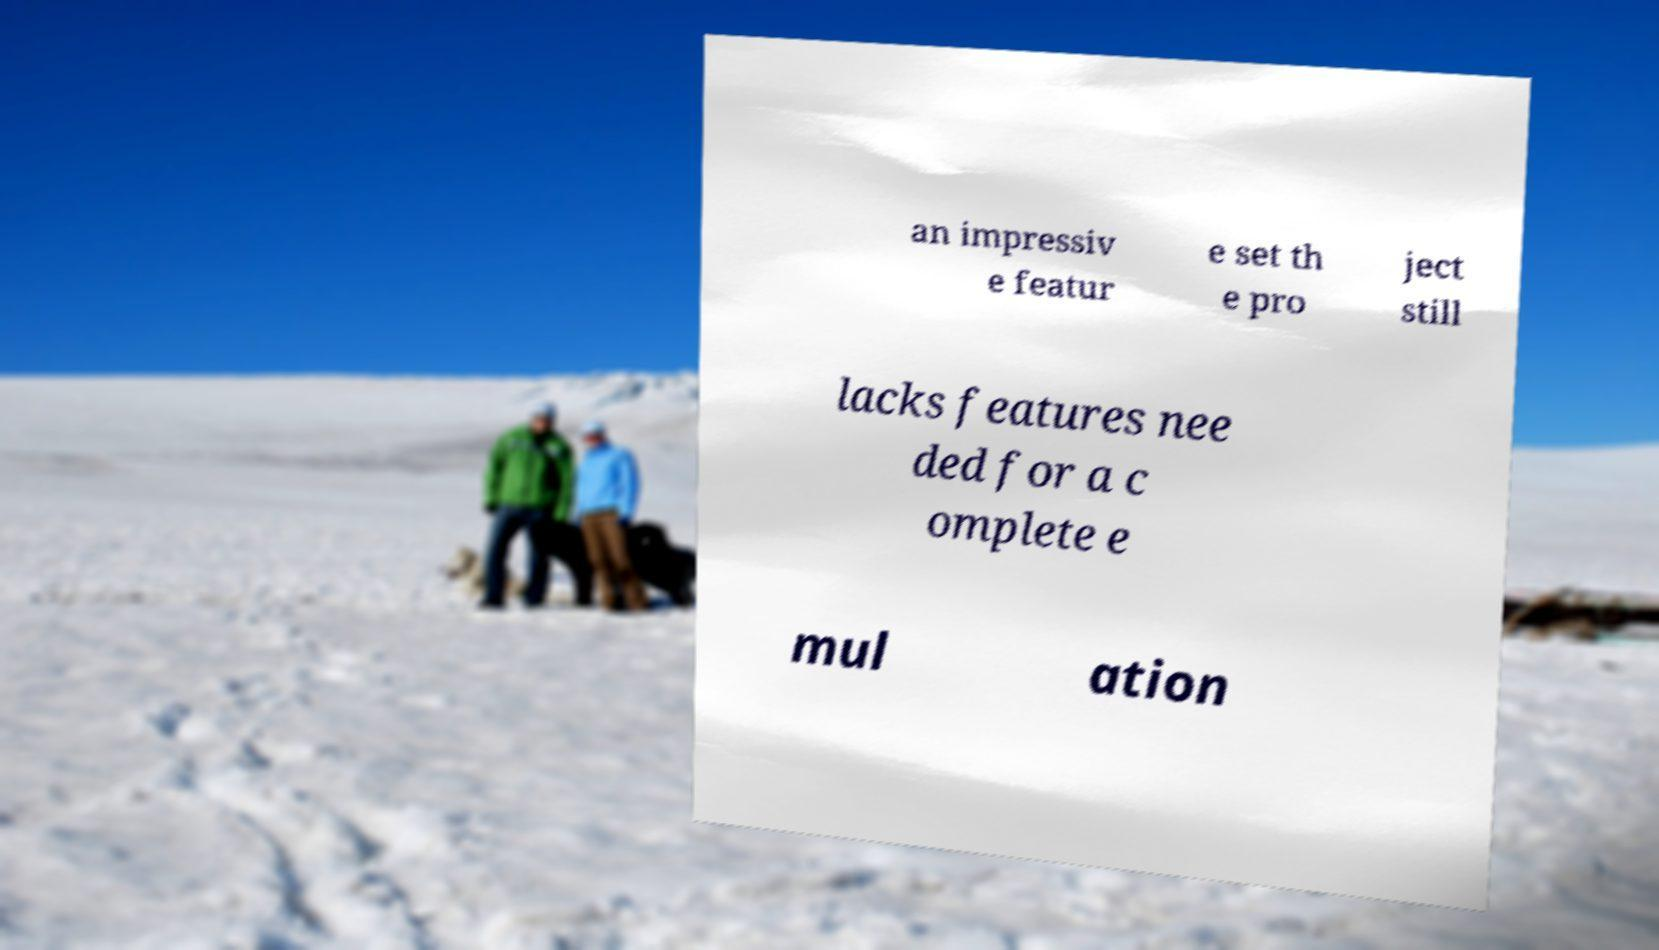Can you accurately transcribe the text from the provided image for me? an impressiv e featur e set th e pro ject still lacks features nee ded for a c omplete e mul ation 